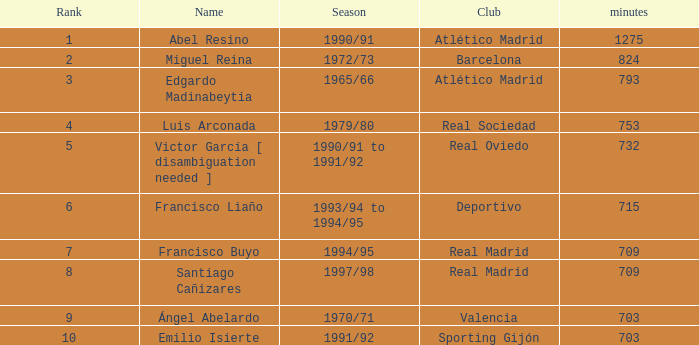What are the minutes of the Player from Real Madrid Club with a Rank of 7 or larger? 709.0. 